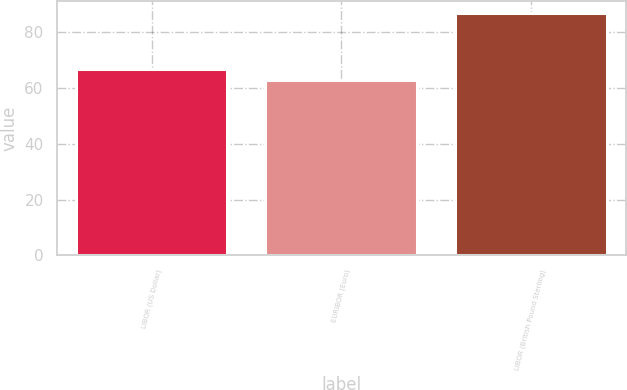Convert chart. <chart><loc_0><loc_0><loc_500><loc_500><bar_chart><fcel>LIBOR (US Dollar)<fcel>EURIBOR (Euro)<fcel>LIBOR (British Pound Sterling)<nl><fcel>67<fcel>63<fcel>87<nl></chart> 